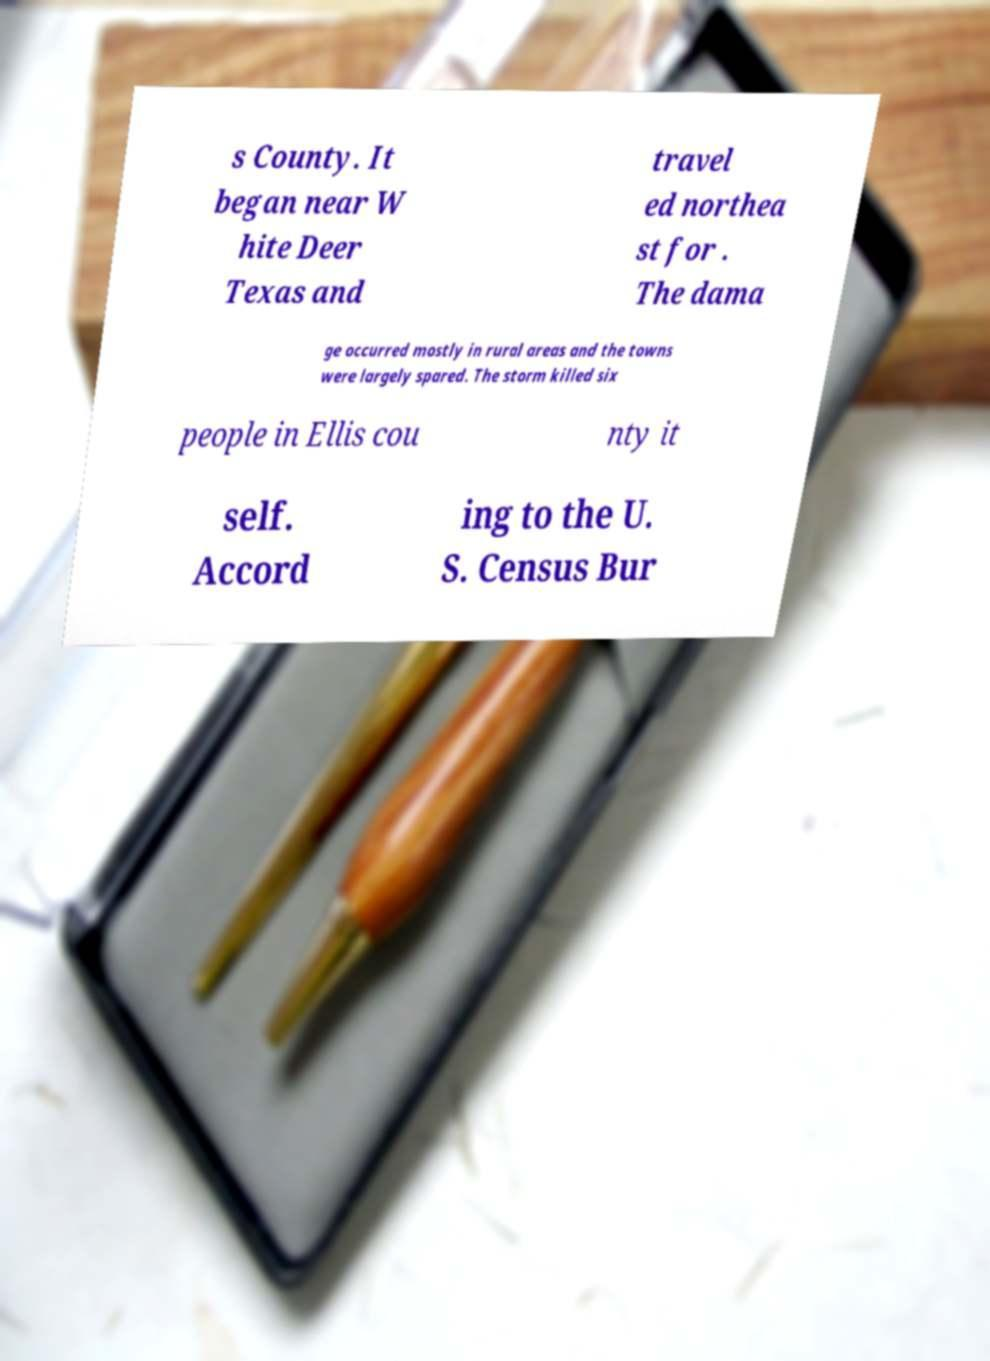Please identify and transcribe the text found in this image. s County. It began near W hite Deer Texas and travel ed northea st for . The dama ge occurred mostly in rural areas and the towns were largely spared. The storm killed six people in Ellis cou nty it self. Accord ing to the U. S. Census Bur 